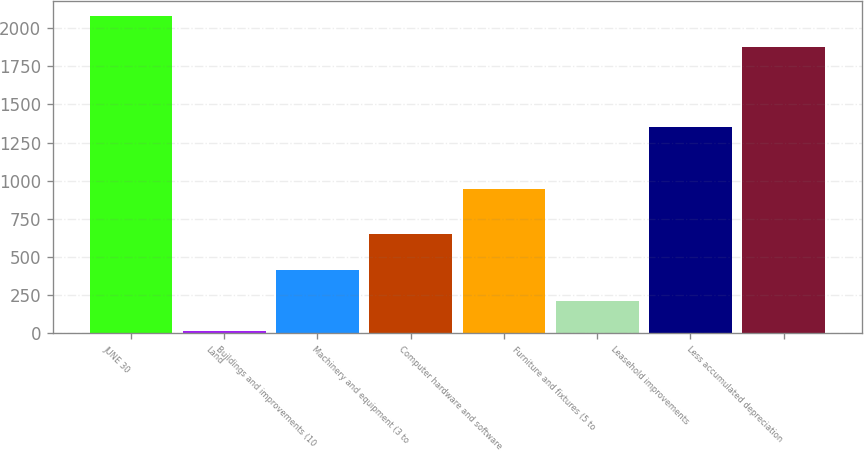<chart> <loc_0><loc_0><loc_500><loc_500><bar_chart><fcel>JUNE 30<fcel>Land<fcel>Buildings and improvements (10<fcel>Machinery and equipment (3 to<fcel>Computer hardware and software<fcel>Furniture and fixtures (5 to<fcel>Leasehold improvements<fcel>Less accumulated depreciation<nl><fcel>2076.73<fcel>14.7<fcel>414.36<fcel>647.9<fcel>948.4<fcel>214.53<fcel>1349.6<fcel>1876.9<nl></chart> 